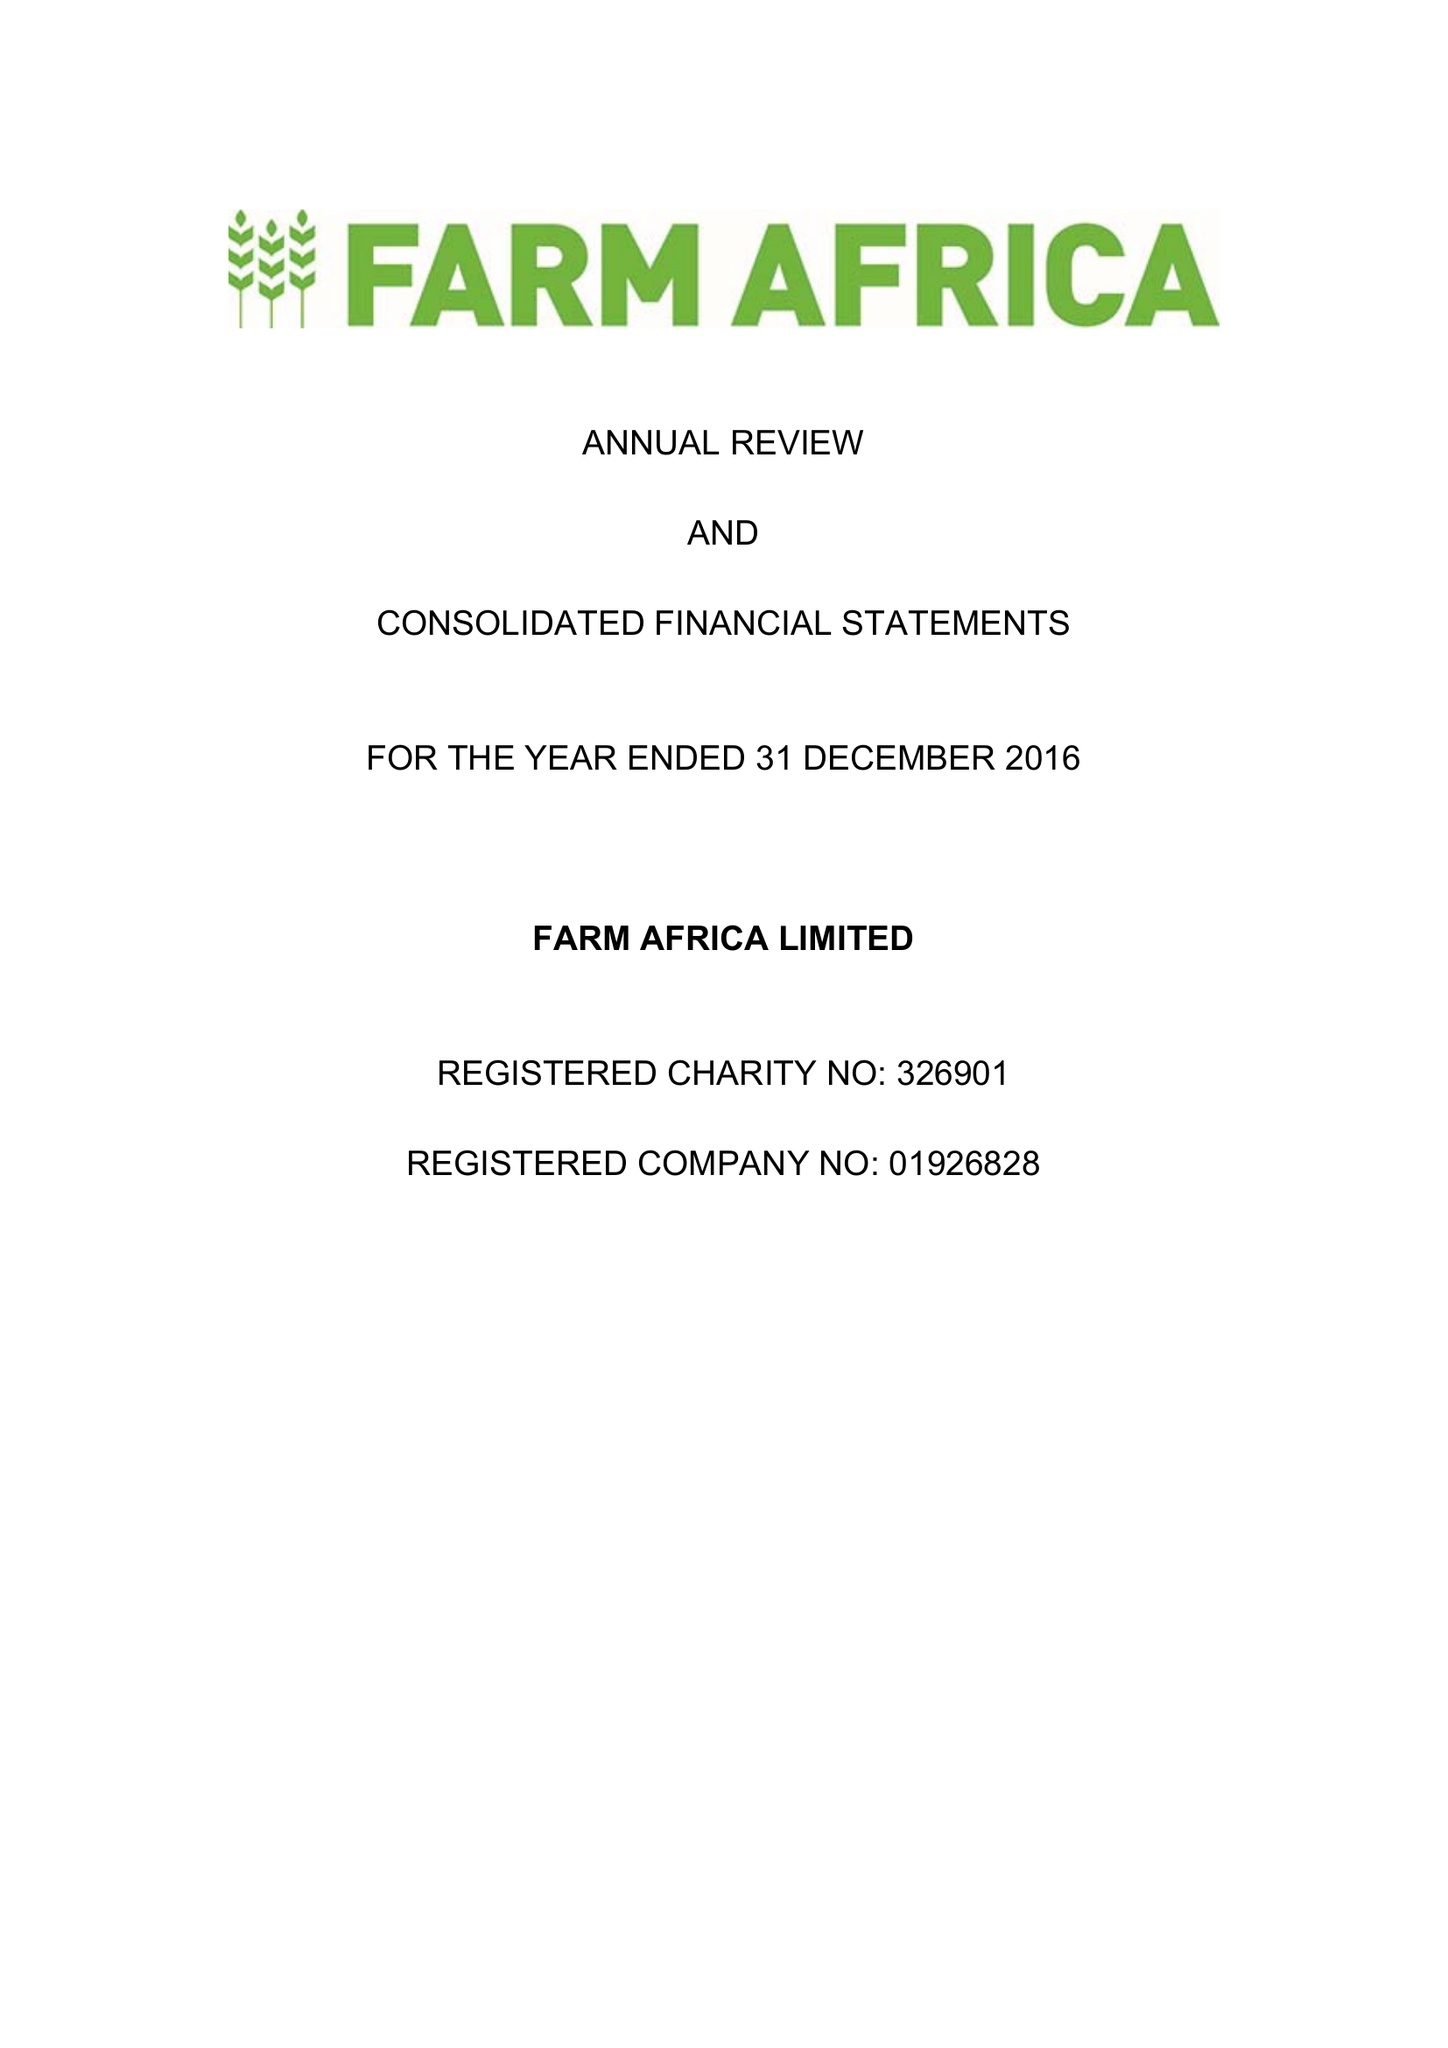What is the value for the charity_name?
Answer the question using a single word or phrase. Farm Africa Ltd. 